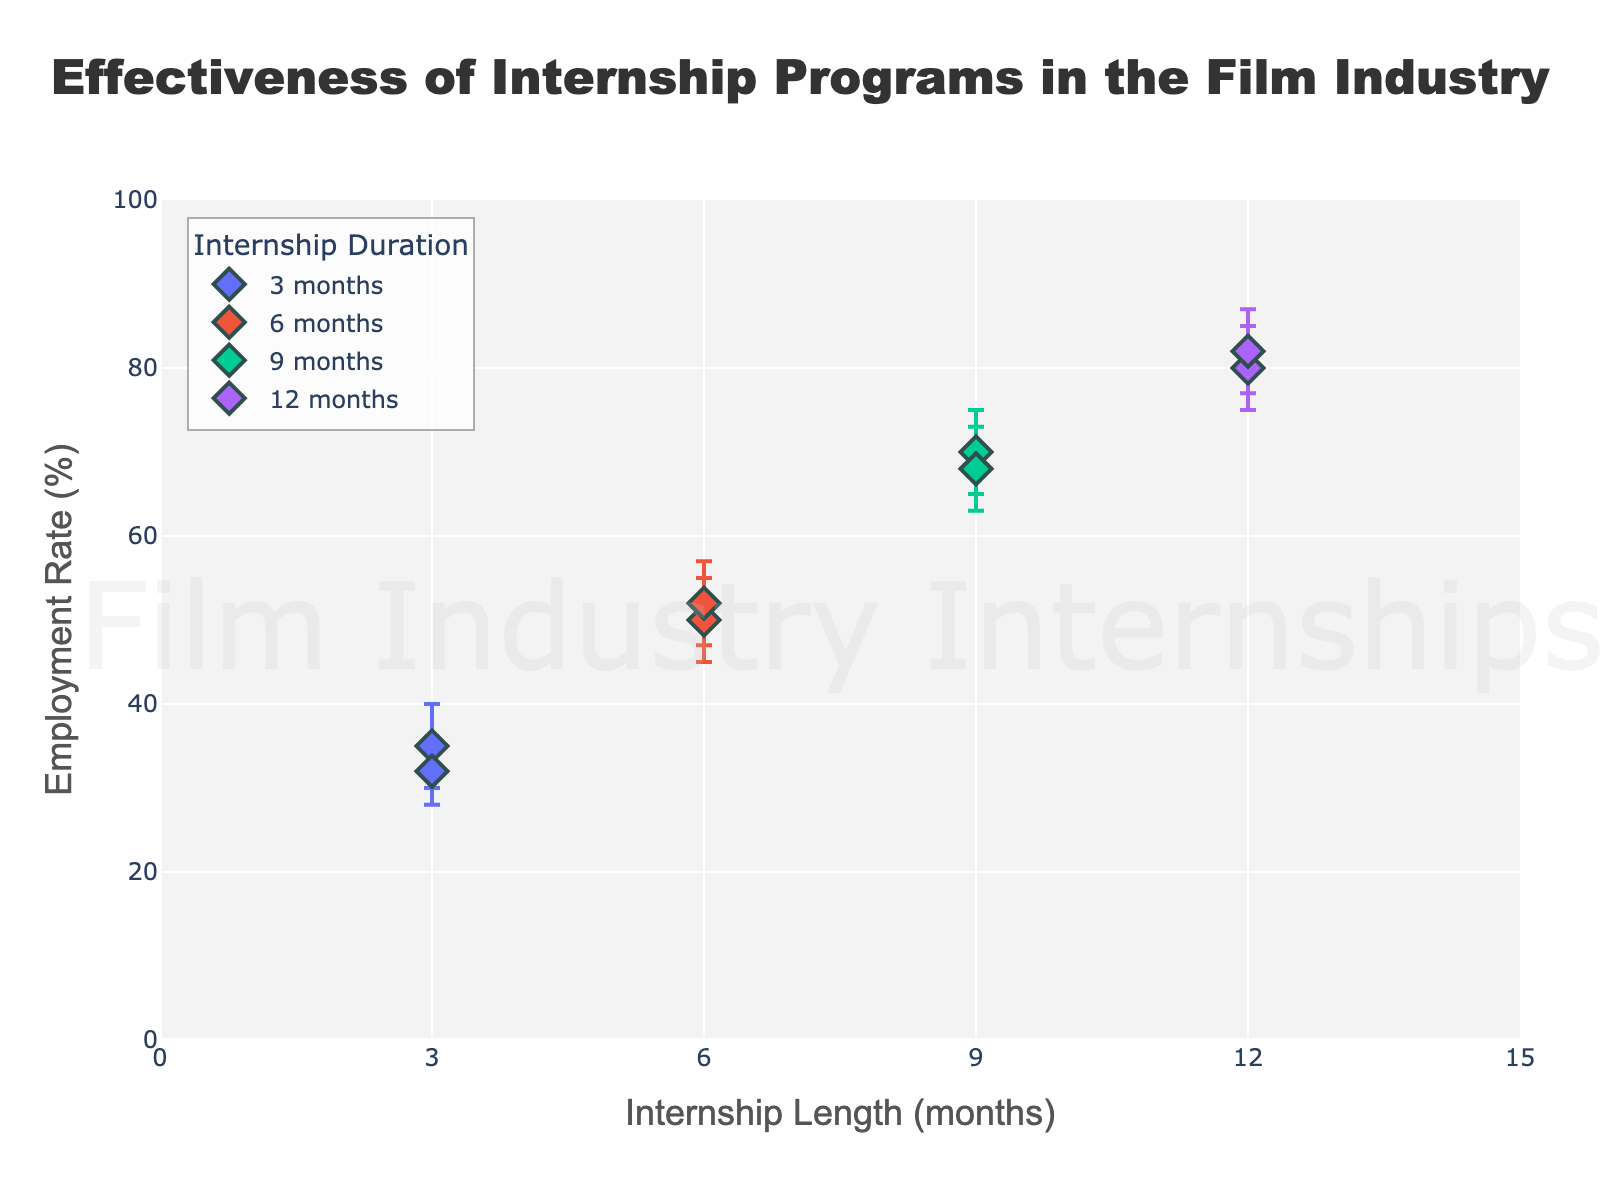What's the title of the figure? The title of the figure is a basic element that is typically displayed prominently at the top. Here, it is "Effectiveness of Internship Programs in the Film Industry".
Answer: Effectiveness of Internship Programs in the Film Industry What is the x-axis representing? The x-axis represents "Internship Length (months)", which indicates the duration of the internships in months.
Answer: Internship Length (months) What is the y-axis representing? The y-axis represents "Employment Rate (%)", which shows the percentage of interns who gain employment after completing the internship programs.
Answer: Employment Rate (%) How many different internship lengths are compared in the figure? The internship lengths are the unique values on the x-axis. According to the data, there are four different lengths: 3, 6, 9, and 12 months.
Answer: 4 Which internship length shows the highest employment rate? By looking at the highest point on the y-axis for each internship length, the 12-month internship shows the highest employment rate.
Answer: 12 months What are the employment rates for the 3-month internship program? There are two data points for the 3-month internship. They show employment rates of 35% and 32%.
Answer: 35% and 32% How does the employment rate change as internship length increases from 3 to 12 months? By observing the general trend in the scatter plot, the employment rate increases as the internship length increases from 3 to 12 months.
Answer: It increases What is the range of employment rates for the 9-month internship program? The range can be determined by the highest and lowest employment rates for the 9-month internship, which are 70% and 68%, respectively. So, the range is from 68% to 70%.
Answer: 68% to 70% What is the average employment rate for the 6-month internship length? The employment rates for the 6-month internship are 50% and 52%. To find the average: (50 + 52) / 2 = 51%.
Answer: 51% Which internship length interval has the narrowest confidence interval for employment rates? Confidence intervals can be assessed by the gap between the "Lower_CI" and "Upper_CI". The 3-month internship has narrower confidence intervals (30-40 and 28-36) compared to other lengths.
Answer: 3 months 